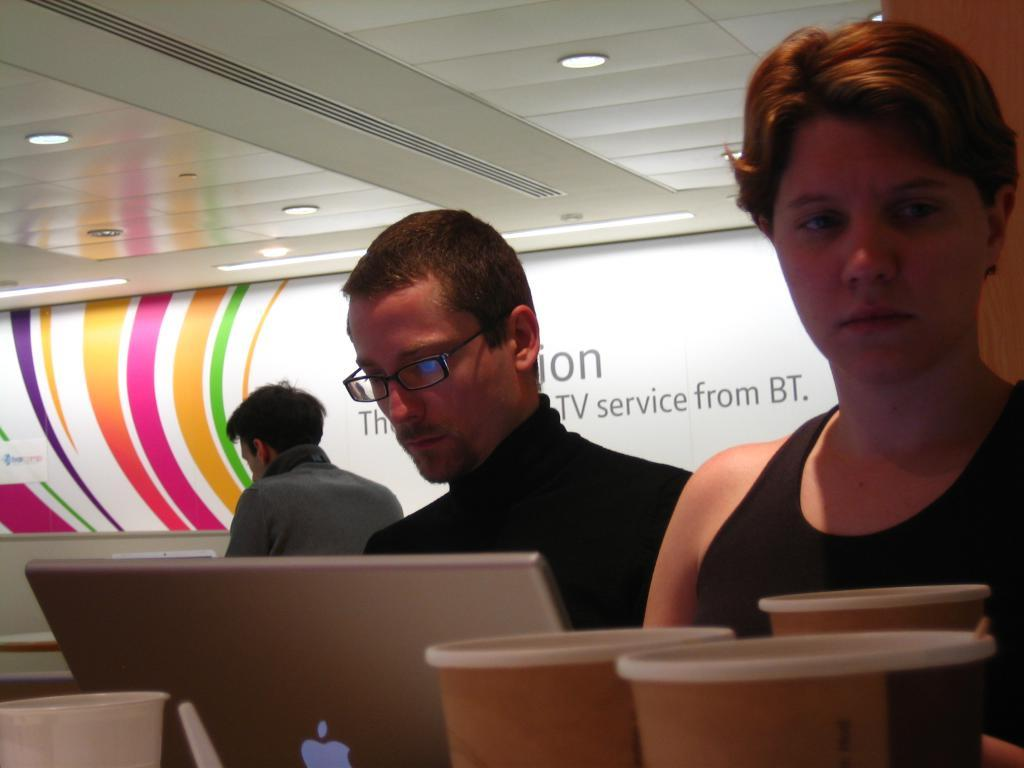How many people are in the image? There are three people in the image. What object is in front of the people? There is a laptop and cups in front of the people. What is behind the people? There is a board behind the people. What type of lighting is visible in the image? There are ceiling lights at the top of the image. Can you tell me how many vans are parked outside the room in the image? There is no information about vans or any outdoor setting in the image; it only shows three people, a laptop, cups, a board, and ceiling lights. 